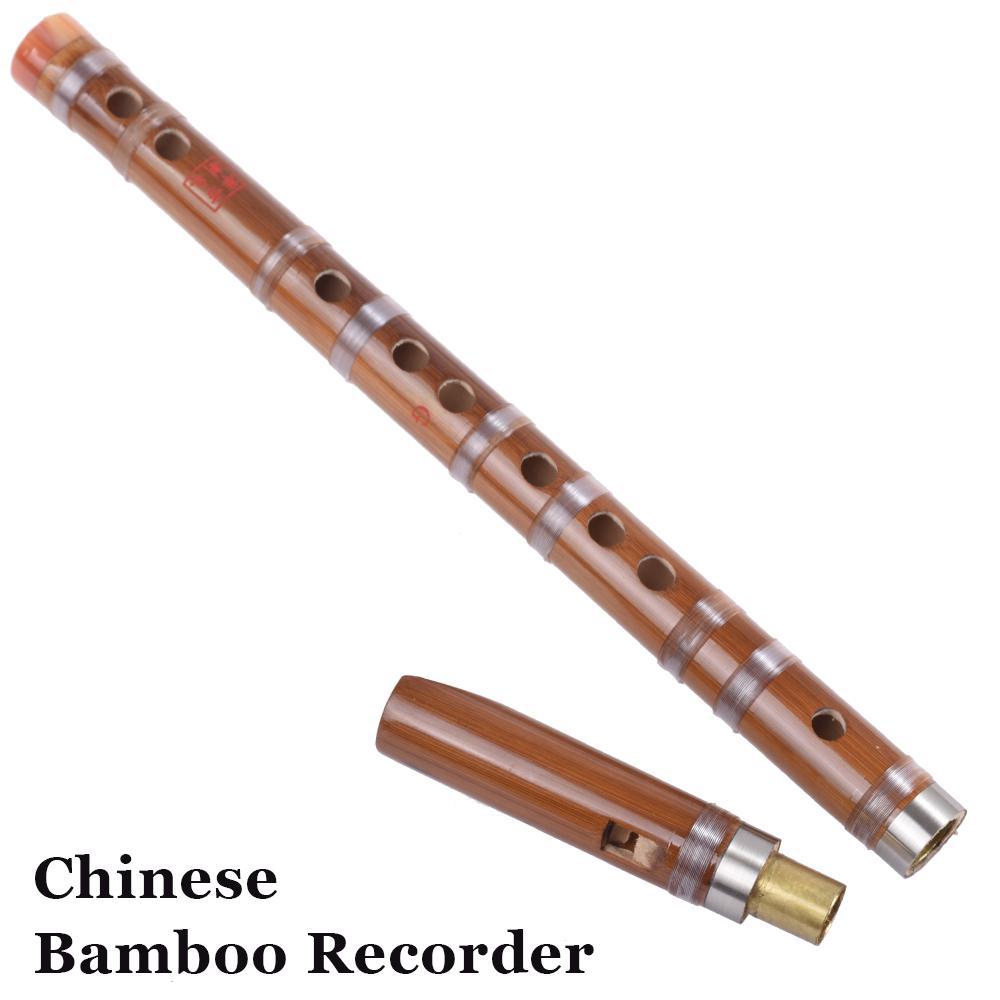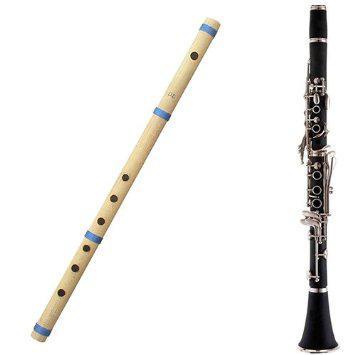The first image is the image on the left, the second image is the image on the right. Analyze the images presented: Is the assertion "The combined images contain one straight black flute with a flared end, one complete wooden flute, and two flute pieces displayed with one end close together." valid? Answer yes or no. Yes. 